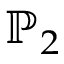Convert formula to latex. <formula><loc_0><loc_0><loc_500><loc_500>\mathbb { P } _ { 2 }</formula> 